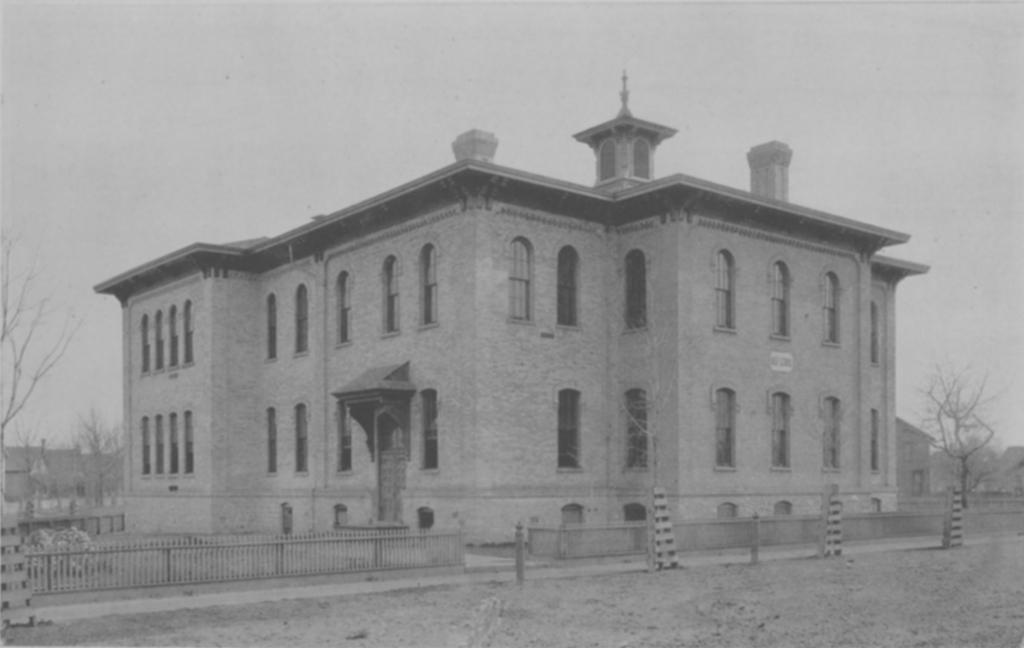What type of structure is present in the image? There is a building in the image. What can be seen surrounding the building? There is a fence in the image. What type of natural elements are present in the image? There are trees in the image. What type of holiday is being celebrated in the image? There is no indication of a holiday being celebrated in the image. What type of medical facility is present in the image? There is no hospital or medical facility present in the image. 